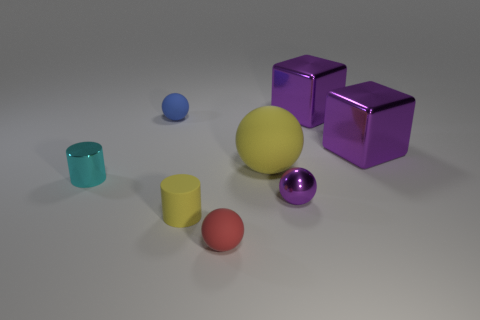Subtract all blue balls. How many balls are left? 3 Add 2 tiny purple things. How many objects exist? 10 Subtract all yellow spheres. How many spheres are left? 3 Subtract 1 cylinders. How many cylinders are left? 1 Subtract all blocks. How many objects are left? 6 Subtract all cyan cylinders. Subtract all green blocks. How many cylinders are left? 1 Subtract all green shiny blocks. Subtract all metal cylinders. How many objects are left? 7 Add 1 tiny cyan shiny objects. How many tiny cyan shiny objects are left? 2 Add 2 metallic cubes. How many metallic cubes exist? 4 Subtract 1 yellow cylinders. How many objects are left? 7 